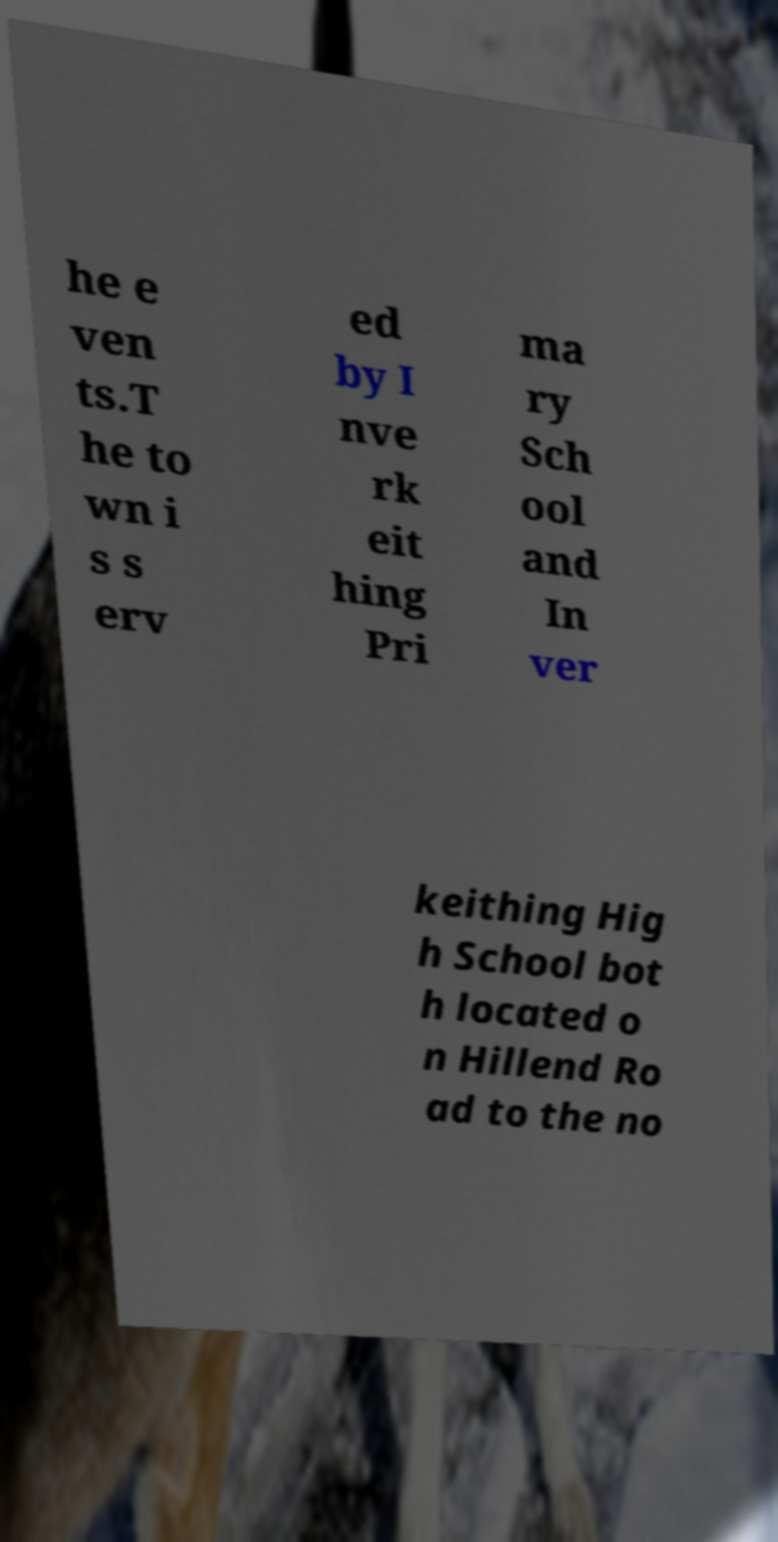Please identify and transcribe the text found in this image. he e ven ts.T he to wn i s s erv ed by I nve rk eit hing Pri ma ry Sch ool and In ver keithing Hig h School bot h located o n Hillend Ro ad to the no 